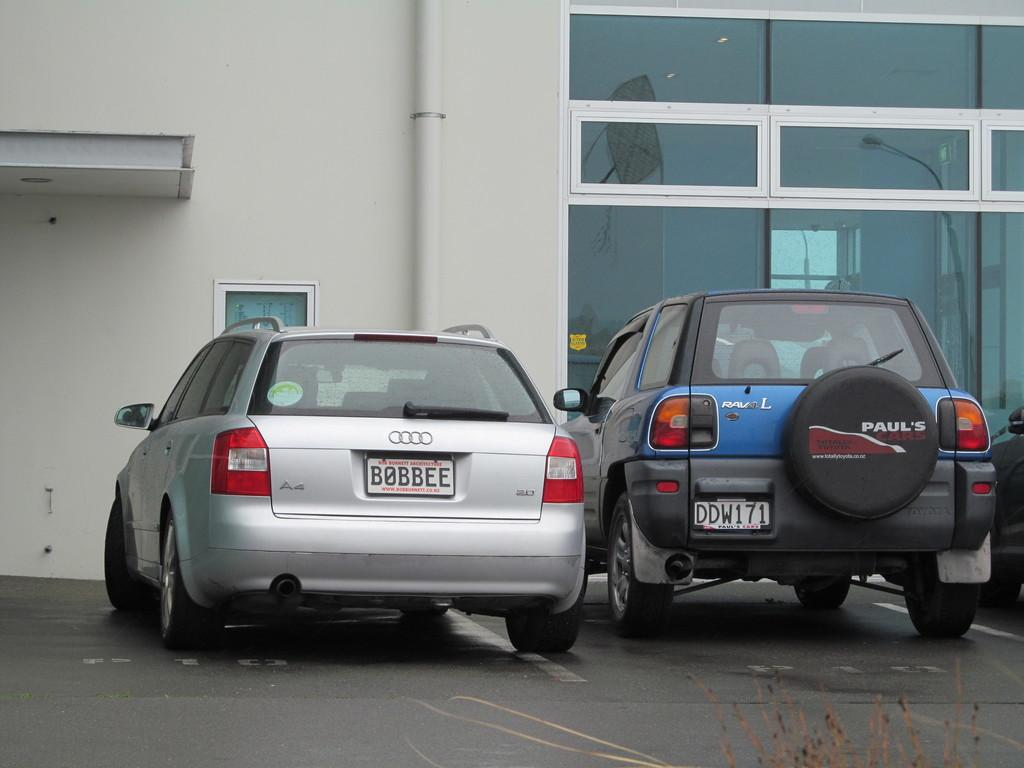How many vehicles are visible in the image? There are two vehicles in the image. What is the location of the vehicles in relation to the wall? The vehicles are in front of a wall. What feature can be seen on the wall? There is a pipe on the wall. Is there any indication of a barrier in the image? There may be a glass fence in the image. What type of plantation can be seen growing near the vehicles in the image? There is no plantation visible in the image; it only features two vehicles, a wall, a pipe, and possibly a glass fence. 